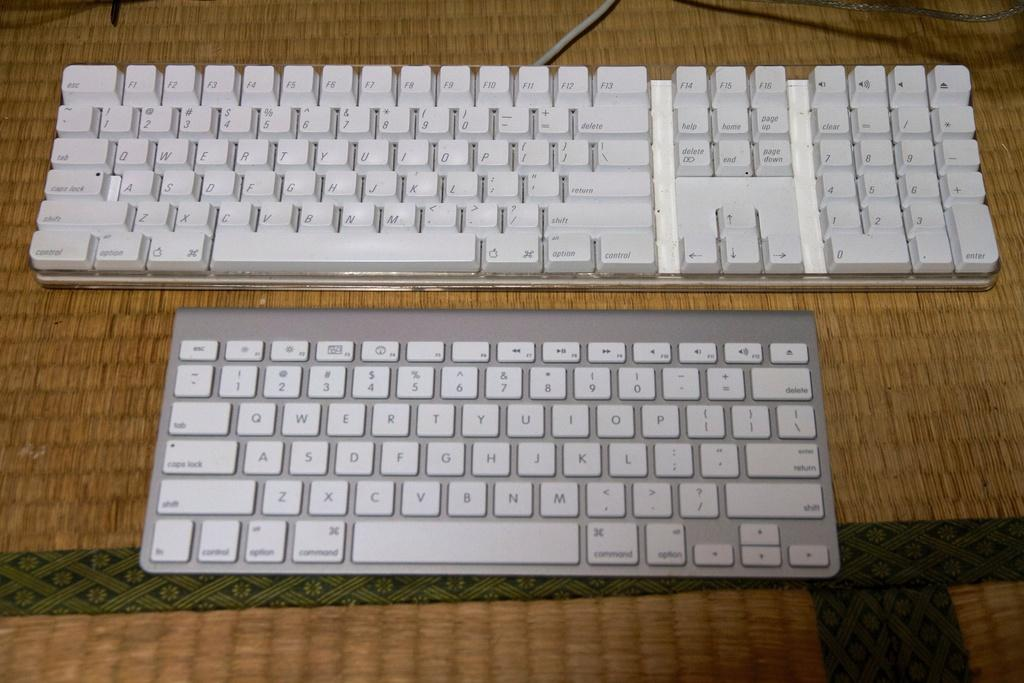<image>
Summarize the visual content of the image. A bigger QWERT keyboard is next to a smaller keyboard on the table 